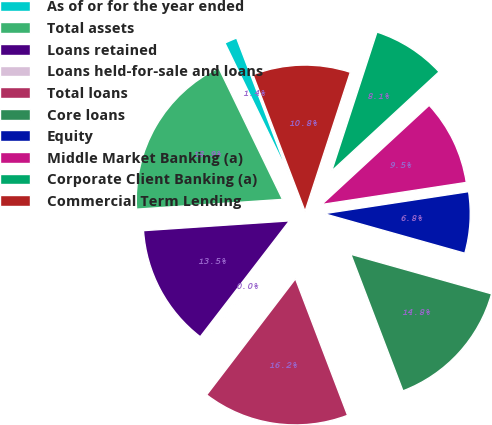Convert chart. <chart><loc_0><loc_0><loc_500><loc_500><pie_chart><fcel>As of or for the year ended<fcel>Total assets<fcel>Loans retained<fcel>Loans held-for-sale and loans<fcel>Total loans<fcel>Core loans<fcel>Equity<fcel>Middle Market Banking (a)<fcel>Corporate Client Banking (a)<fcel>Commercial Term Lending<nl><fcel>1.39%<fcel>18.88%<fcel>13.5%<fcel>0.05%<fcel>16.19%<fcel>14.84%<fcel>6.77%<fcel>9.46%<fcel>8.12%<fcel>10.81%<nl></chart> 